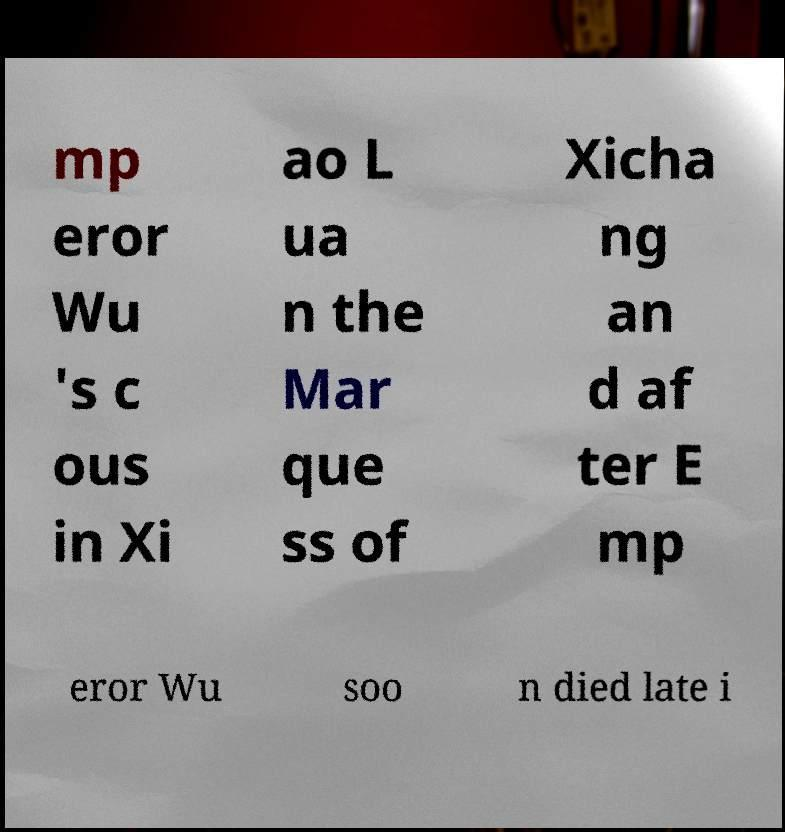I need the written content from this picture converted into text. Can you do that? mp eror Wu 's c ous in Xi ao L ua n the Mar que ss of Xicha ng an d af ter E mp eror Wu soo n died late i 